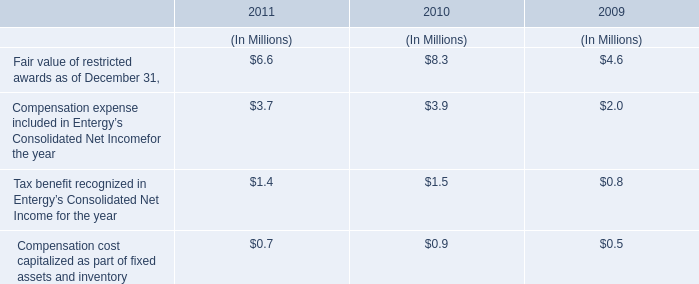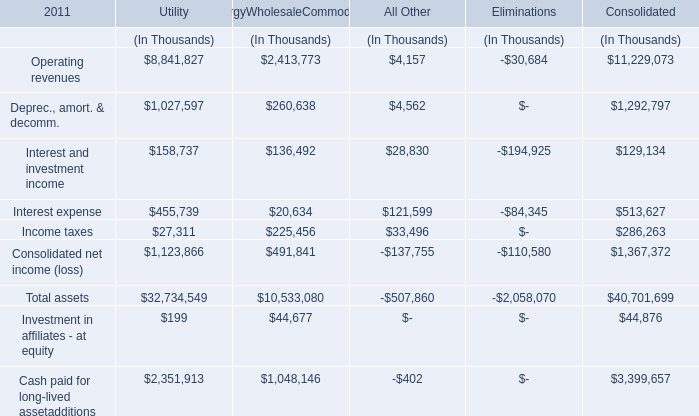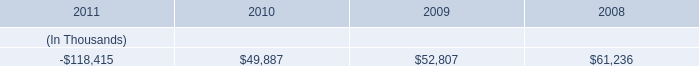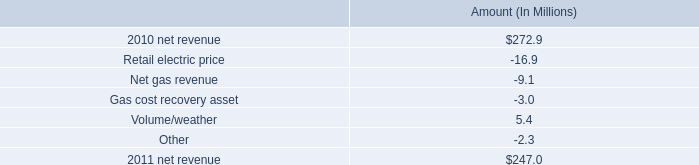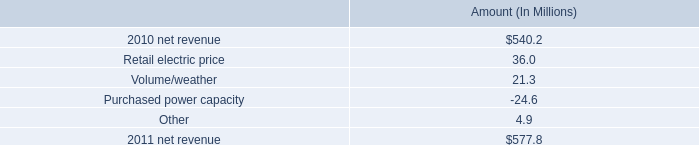what was the ratio of the net income to the revenues in 2010 
Computations: (2.4 / 540.2)
Answer: 0.00444. 